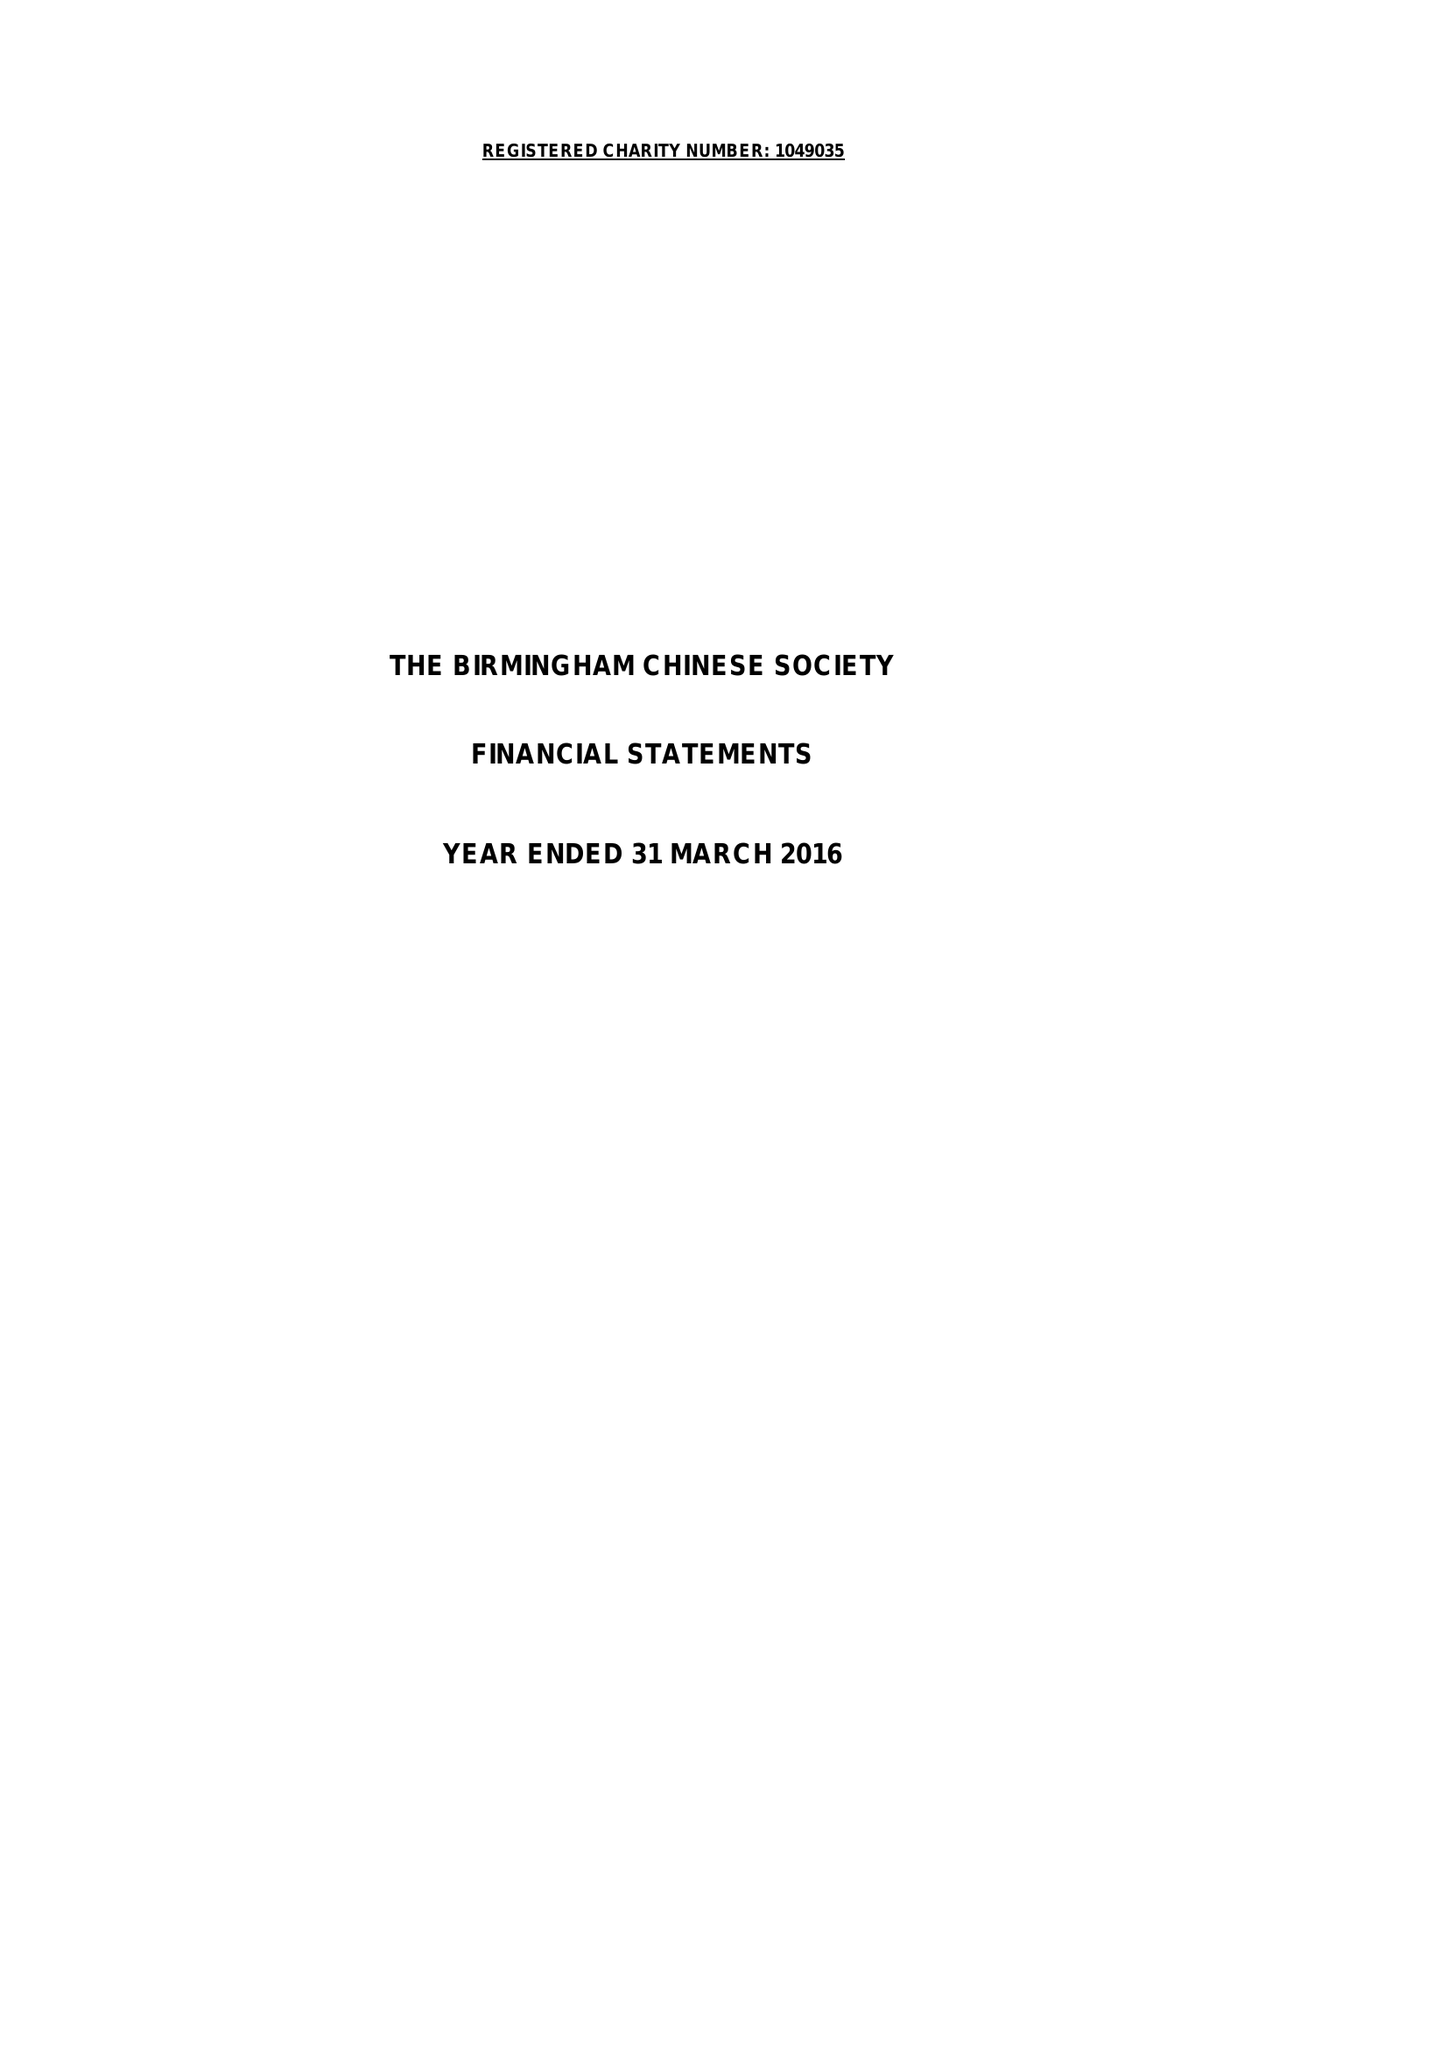What is the value for the address__post_town?
Answer the question using a single word or phrase. BIRMINGHAM 